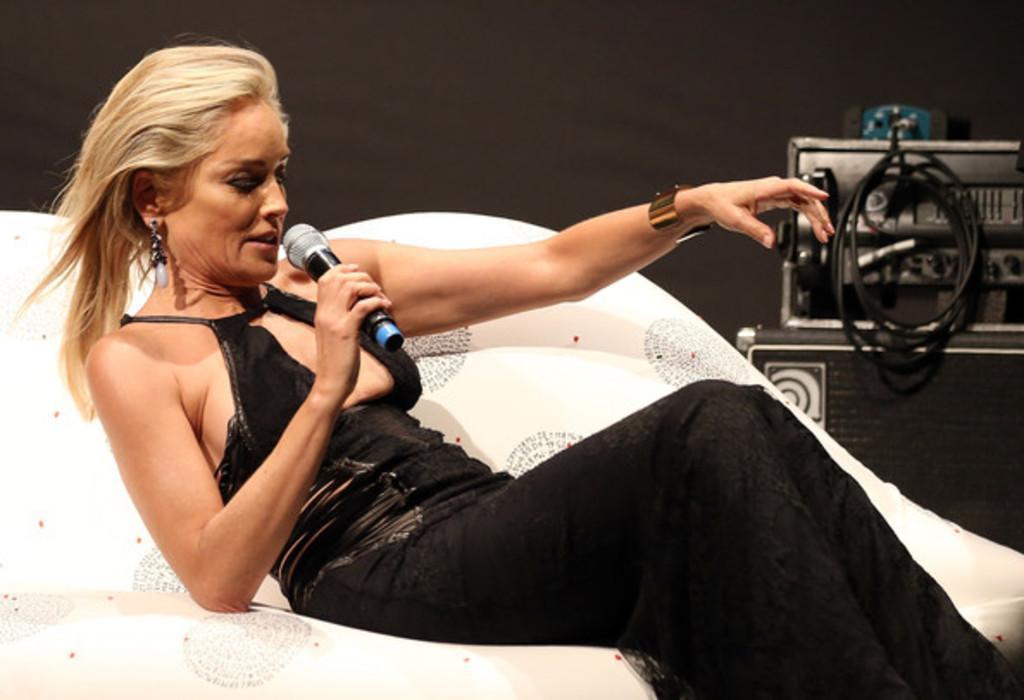Describe this image in one or two sentences. In this image a lady is sitting and holding a microphone. There is an object placed at the right most of the image. 